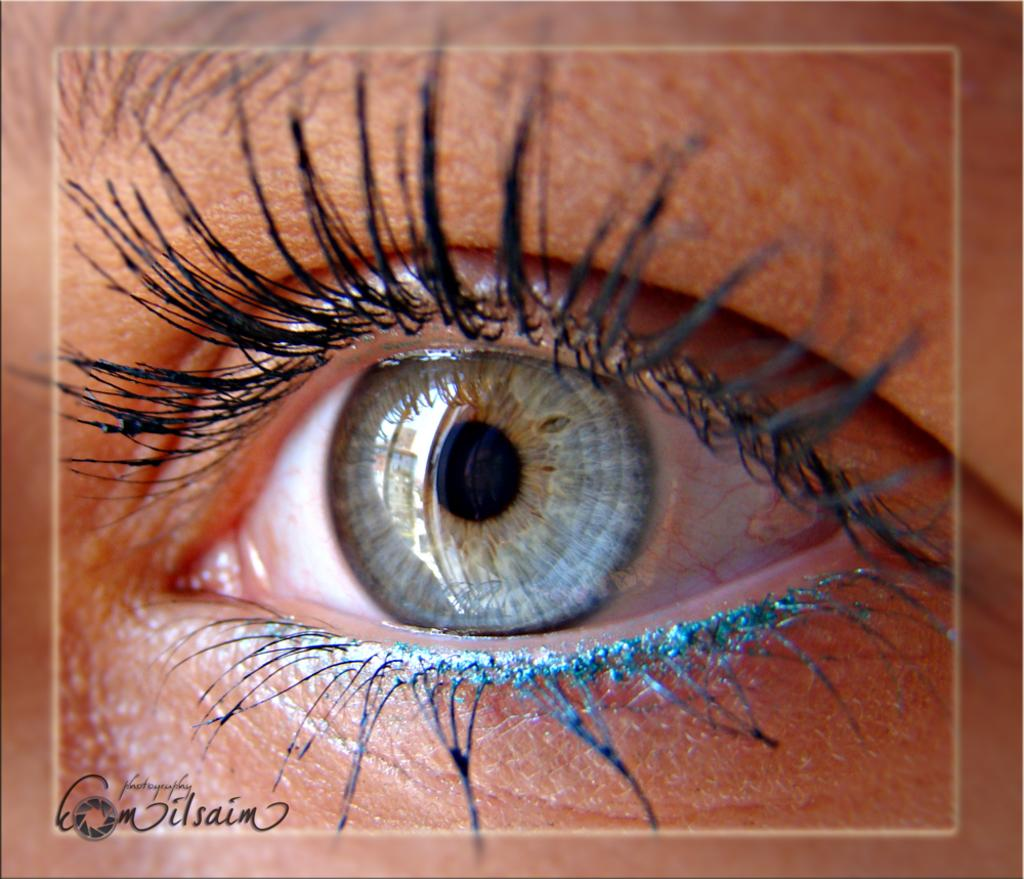What is the main subject of the image? The main subject of the image is a human eye. What can be observed about the eyelashes in the image? The eye has black eyelashes. How many colors are present in the iris of the eye? The iris has three colors: black, purple, and blue-green. What type of book is the judge holding in the image? There is no book or judge present in the image; it features a human eye with specific details about its appearance. What is the size of the eye in the image? The size of the eye cannot be determined from the image alone, as it is a two-dimensional representation. 